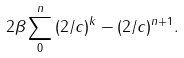Convert formula to latex. <formula><loc_0><loc_0><loc_500><loc_500>2 \beta \sum _ { 0 } ^ { n } { ( 2 / c ) } ^ { k } - { ( 2 / c ) } ^ { n + 1 } .</formula> 